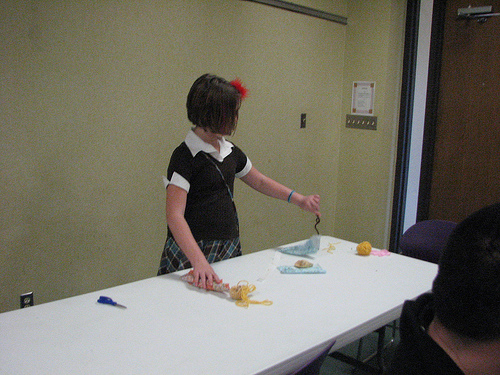<image>
Is there a rubber band in the room? Yes. The rubber band is contained within or inside the room, showing a containment relationship. 